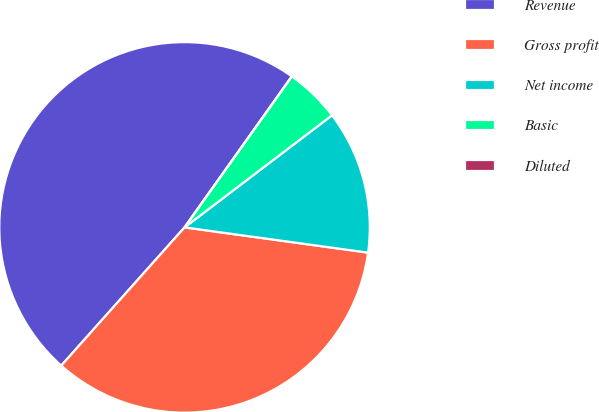Convert chart. <chart><loc_0><loc_0><loc_500><loc_500><pie_chart><fcel>Revenue<fcel>Gross profit<fcel>Net income<fcel>Basic<fcel>Diluted<nl><fcel>48.24%<fcel>34.42%<fcel>12.52%<fcel>4.82%<fcel>0.0%<nl></chart> 